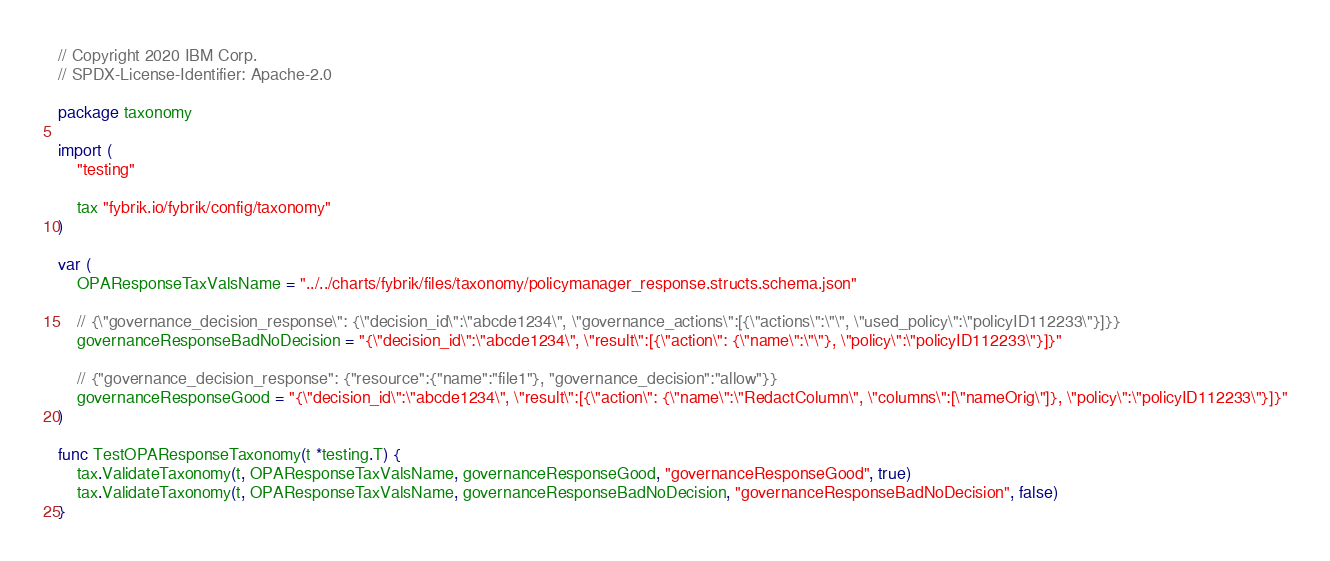<code> <loc_0><loc_0><loc_500><loc_500><_Go_>// Copyright 2020 IBM Corp.
// SPDX-License-Identifier: Apache-2.0

package taxonomy

import (
	"testing"

	tax "fybrik.io/fybrik/config/taxonomy"
)

var (
	OPAResponseTaxValsName = "../../charts/fybrik/files/taxonomy/policymanager_response.structs.schema.json"

	// {\"governance_decision_response\": {\"decision_id\":\"abcde1234\", \"governance_actions\":[{\"actions\":\"\", \"used_policy\":\"policyID112233\"}]}}
	governanceResponseBadNoDecision = "{\"decision_id\":\"abcde1234\", \"result\":[{\"action\": {\"name\":\"\"}, \"policy\":\"policyID112233\"}]}"

	// {"governance_decision_response": {"resource":{"name":"file1"}, "governance_decision":"allow"}}
	governanceResponseGood = "{\"decision_id\":\"abcde1234\", \"result\":[{\"action\": {\"name\":\"RedactColumn\", \"columns\":[\"nameOrig\"]}, \"policy\":\"policyID112233\"}]}"
)

func TestOPAResponseTaxonomy(t *testing.T) {
	tax.ValidateTaxonomy(t, OPAResponseTaxValsName, governanceResponseGood, "governanceResponseGood", true)
	tax.ValidateTaxonomy(t, OPAResponseTaxValsName, governanceResponseBadNoDecision, "governanceResponseBadNoDecision", false)
}
</code> 